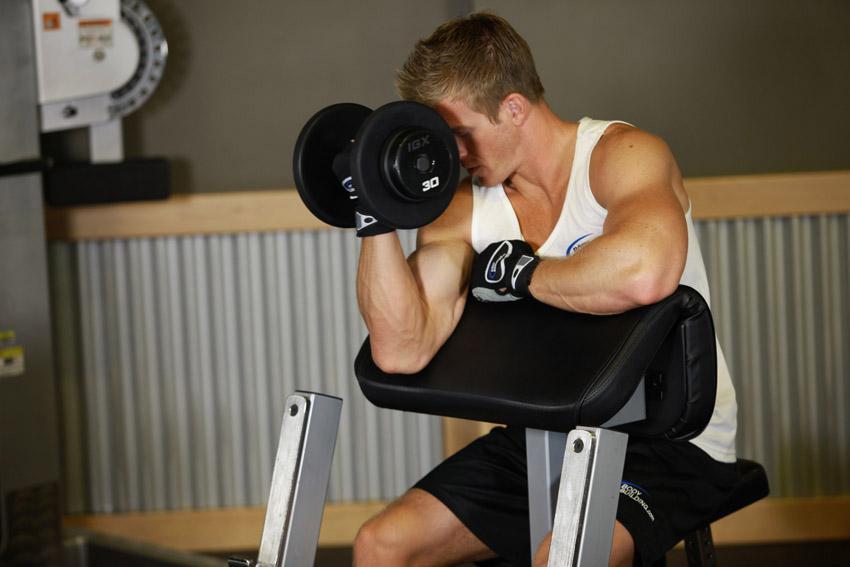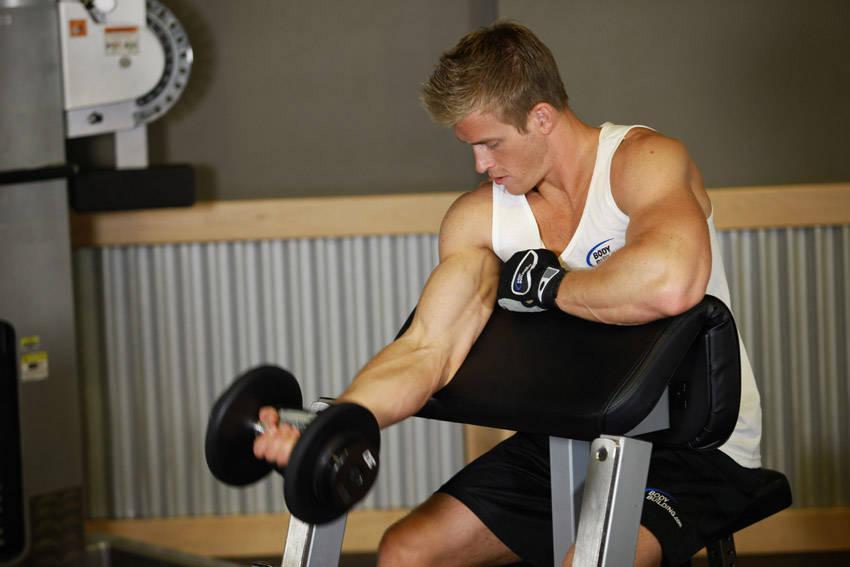The first image is the image on the left, the second image is the image on the right. Assess this claim about the two images: "there is a male with a dumbbell near his face". Correct or not? Answer yes or no. Yes. 